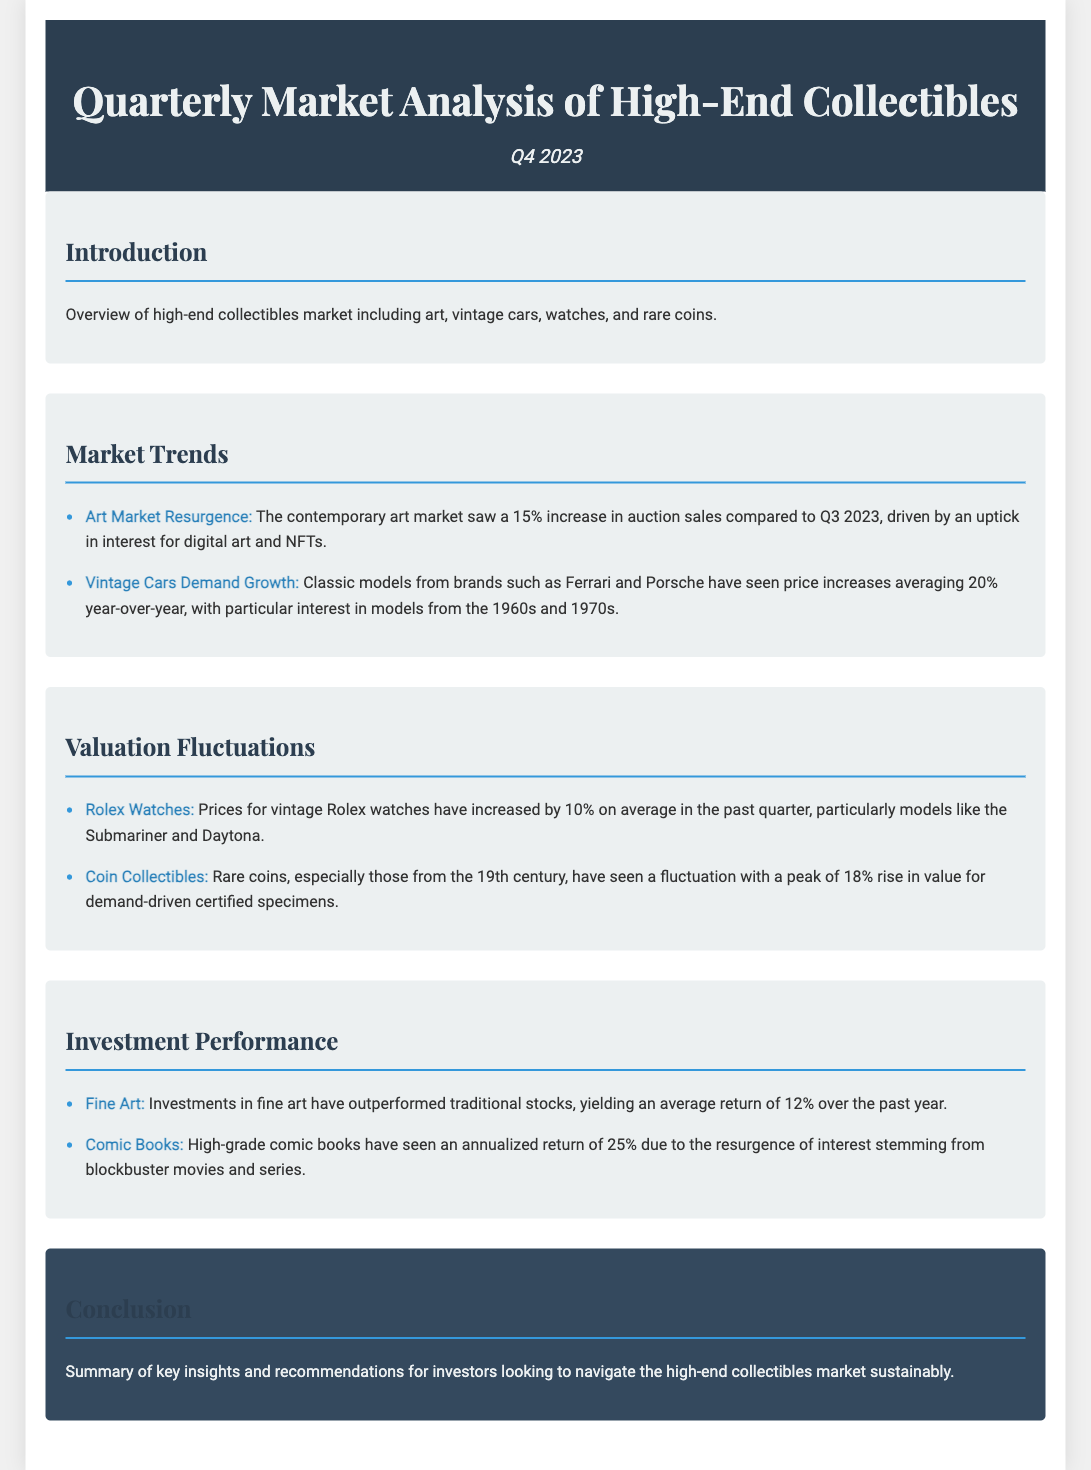What was the percentage increase in auction sales for the contemporary art market compared to Q3 2023? The contemporary art market saw a 15% increase in auction sales compared to Q3 2023.
Answer: 15% What classic vintage car brands have seen price increases averaging 20% year-over-year? Classic models from brands such as Ferrari and Porsche have seen price increases.
Answer: Ferrari and Porsche What is the average price increase for vintage Rolex watches in the past quarter? Prices for vintage Rolex watches have increased by 10% on average in the past quarter.
Answer: 10% What was the annualized return for high-grade comic books? High-grade comic books have seen an annualized return of 25%.
Answer: 25% Which segment outperformed traditional stocks in investment performance? Investments in fine art have outperformed traditional stocks.
Answer: Fine Art What type of collectible saw an 18% rise in value? Rare coins, especially those from the 19th century, have seen a fluctuation with a peak of 18% rise in value.
Answer: Rare coins What is the title of the document? The title of the document is found at the header section.
Answer: Quarterly Market Analysis of High-End Collectibles What was the focus of the market trends section? The market trends section focused on the resurgence in the art market and vintage cars demand growth.
Answer: Art Market Resurgence and Vintage Cars Demand Growth What section follows the Valuation Fluctuations in the document? The section following Valuation Fluctuations is the Investment Performance section.
Answer: Investment Performance 